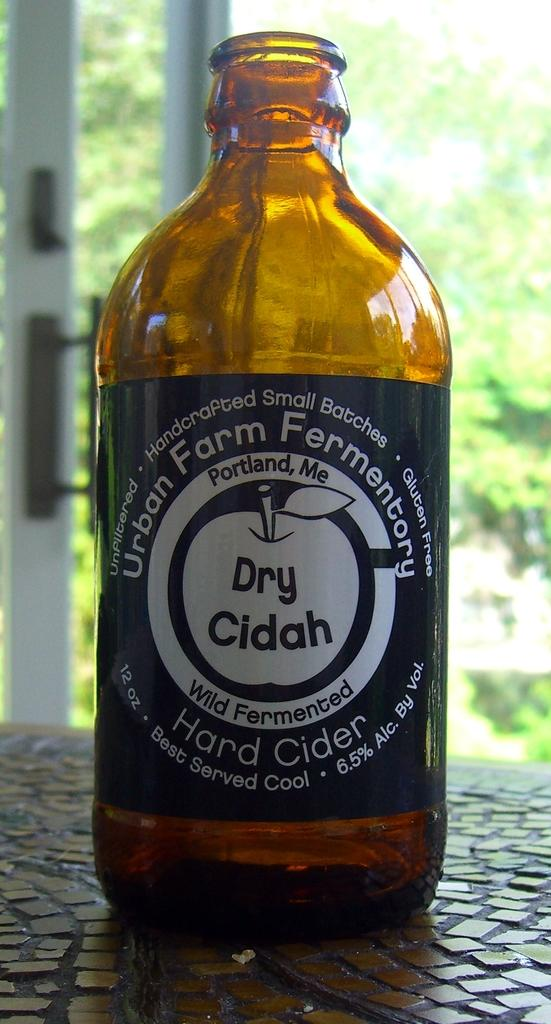<image>
Write a terse but informative summary of the picture. A bottle of Urban Farm Fermentory Hard Cider 